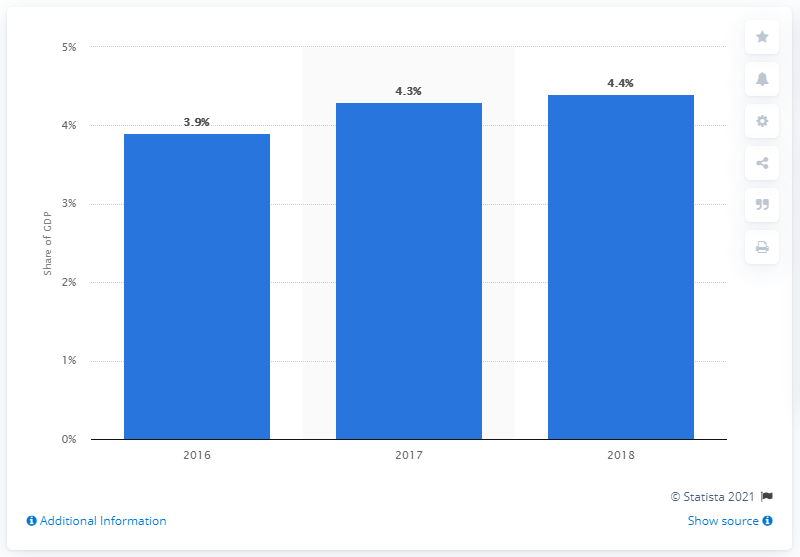List a handful of essential elements in this visual. In 2018, the tourism industry contributed 4.4% to the gross domestic product of the Netherlands. 